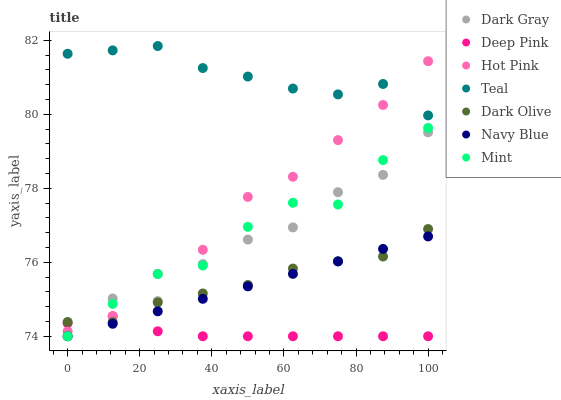Does Deep Pink have the minimum area under the curve?
Answer yes or no. Yes. Does Teal have the maximum area under the curve?
Answer yes or no. Yes. Does Navy Blue have the minimum area under the curve?
Answer yes or no. No. Does Navy Blue have the maximum area under the curve?
Answer yes or no. No. Is Navy Blue the smoothest?
Answer yes or no. Yes. Is Dark Gray the roughest?
Answer yes or no. Yes. Is Dark Olive the smoothest?
Answer yes or no. No. Is Dark Olive the roughest?
Answer yes or no. No. Does Deep Pink have the lowest value?
Answer yes or no. Yes. Does Dark Olive have the lowest value?
Answer yes or no. No. Does Teal have the highest value?
Answer yes or no. Yes. Does Navy Blue have the highest value?
Answer yes or no. No. Is Deep Pink less than Teal?
Answer yes or no. Yes. Is Teal greater than Deep Pink?
Answer yes or no. Yes. Does Deep Pink intersect Dark Olive?
Answer yes or no. Yes. Is Deep Pink less than Dark Olive?
Answer yes or no. No. Is Deep Pink greater than Dark Olive?
Answer yes or no. No. Does Deep Pink intersect Teal?
Answer yes or no. No. 